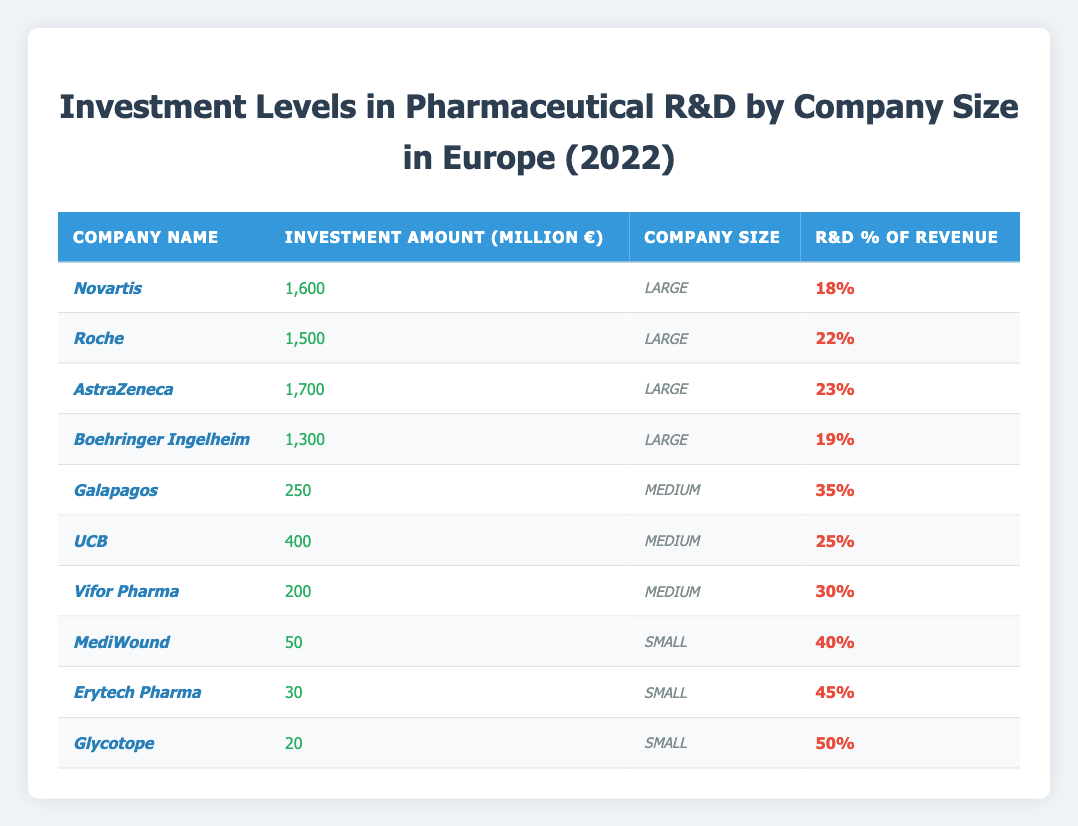What is the total investment amount for large pharmaceutical companies? The investment amounts for large companies are 1,600 (Novartis) + 1,500 (Roche) + 1,700 (AstraZeneca) + 1,300 (Boehringer Ingelheim). Adding these values gives 1,600 + 1,500 + 1,700 + 1,300 = 6,100 million euros.
Answer: 6,100 million euros Which small company has the highest R&D percentage of revenue? The R&D percentages for small companies are 40% (MediWound), 45% (Erytech Pharma), and 50% (Glycotope). The highest percentage is 50%, associated with Glycotope.
Answer: Glycotope How many companies listed have an R&D percentage of revenue above 30%? The percentages above 30% are Galapagos (35%), UCB (25%), Vifor Pharma (30%), MediWound (40%), Erytech Pharma (45%), and Glycotope (50%). Counting them gives us 5 companies.
Answer: 5 companies What is the average R&D percentage of revenue for medium-sized companies? The R&D percentages for medium companies are 35% (Galapagos), 25% (UCB), and 30% (Vifor Pharma). Their sum is 35 + 25 + 30 = 90. Therefore, the average is 90/3 = 30%.
Answer: 30% Is the total investment for small companies less than that for large companies? The total investment for small companies is 50 (MediWound) + 30 (Erytech Pharma) + 20 (Glycotope) = 100 million euros. The total for large companies is previously calculated as 6,100 million euros. Since 100 million is less than 6,100 million, the statement is true.
Answer: Yes Which large company has the highest investment in R&D? The investment amounts for large companies are 1,600 (Novartis), 1,500 (Roche), 1,700 (AstraZeneca), and 1,300 (Boehringer Ingelheim). The highest amount is 1,700 million euros, from AstraZeneca.
Answer: AstraZeneca What percentage of the total investment is contributed by medium-sized companies? The total investment for medium companies is 250 (Galapagos) + 400 (UCB) + 200 (Vifor Pharma) = 850 million euros. The total investment from all companies is 6,100 + 850 + 100 = 7,050 million euros. The percentage is calculated as (850 / 7,050) × 100 ≈ 12.06%.
Answer: Approximately 12.06% Are all small companies investing less than large companies? Large companies have investments of 1,600, 1,500, 1,700, and 1,300 million euros, while small companies have 50 (MediWound), 30 (Erytech Pharma), and 20 (Glycotope) million euros. All small companies' investments are below those of large companies, confirming the statement is true.
Answer: Yes What is the combined R&D percentage of revenue for all company sizes? The combined R&D percentages are 18 (Novartis) + 22 (Roche) + 23 (AstraZeneca) + 19 (Boehringer Ingelheim) + 35 (Galapagos) + 25 (UCB) + 30 (Vifor Pharma) + 40 (MediWound) + 45 (Erytech Pharma) + 50 (Glycotope) = 392. Dividing this by the total number of companies, which is 10, gives an average of 39.2%.
Answer: 39.2% 